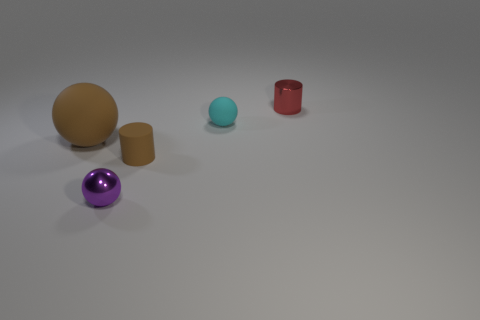What is the color of the other big thing that is the same shape as the purple thing?
Offer a very short reply. Brown. There is a red object; does it have the same shape as the brown object on the right side of the tiny purple sphere?
Offer a terse response. Yes. There is a cyan object that is the same shape as the purple shiny thing; what is its size?
Provide a succinct answer. Small. What number of other objects are there of the same color as the large ball?
Provide a succinct answer. 1. Is the big matte thing the same color as the small matte cylinder?
Give a very brief answer. Yes. The matte object that is on the left side of the shiny object in front of the cyan rubber object is what color?
Offer a very short reply. Brown. What number of spheres are both behind the purple sphere and on the left side of the brown cylinder?
Your answer should be compact. 1. How many purple shiny objects are the same shape as the small cyan matte thing?
Ensure brevity in your answer.  1. Is the large ball made of the same material as the tiny brown cylinder?
Give a very brief answer. Yes. What shape is the metallic thing in front of the rubber thing that is to the left of the small purple object?
Give a very brief answer. Sphere. 